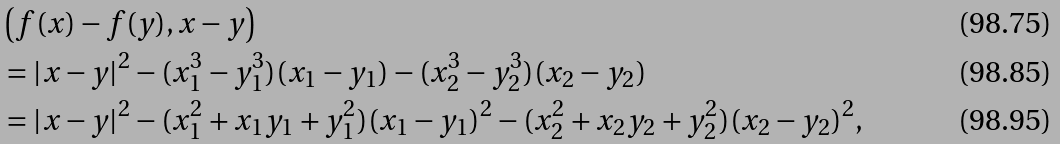<formula> <loc_0><loc_0><loc_500><loc_500>& \left ( f ( x ) - f ( y ) , x - y \right ) \\ & = | x - y | ^ { 2 } - ( x _ { 1 } ^ { 3 } - y _ { 1 } ^ { 3 } ) ( x _ { 1 } - y _ { 1 } ) - ( x _ { 2 } ^ { 3 } - y _ { 2 } ^ { 3 } ) ( x _ { 2 } - y _ { 2 } ) \\ & = | x - y | ^ { 2 } - ( x _ { 1 } ^ { 2 } + x _ { 1 } y _ { 1 } + y _ { 1 } ^ { 2 } ) ( x _ { 1 } - y _ { 1 } ) ^ { 2 } - ( x _ { 2 } ^ { 2 } + x _ { 2 } y _ { 2 } + y _ { 2 } ^ { 2 } ) ( x _ { 2 } - y _ { 2 } ) ^ { 2 } ,</formula> 